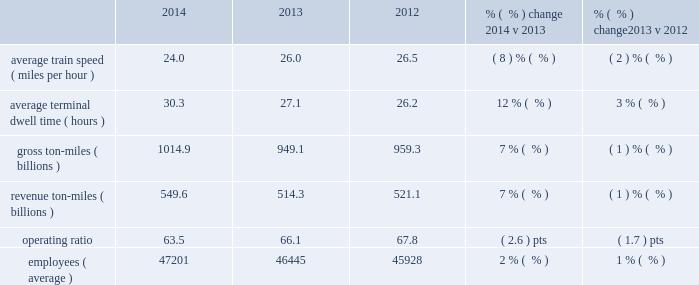Interest expense 2013 interest expense increased in 2014 versus 2013 due to an increased weighted- average debt level of $ 10.8 billion in 2014 from $ 9.6 billion in 2013 , which more than offset the impact of the lower effective interest rate of 5.3% ( 5.3 % ) in 2014 versus 5.7% ( 5.7 % ) in 2013 .
Interest expense decreased in 2013 versus 2012 due to a lower effective interest rate of 5.7% ( 5.7 % ) in 2013 versus 6.0% ( 6.0 % ) in 2012 .
The increase in the weighted-average debt level to $ 9.6 billion in 2013 from $ 9.1 billion in 2012 partially offset the impact of the lower effective interest rate .
Income taxes 2013 higher pre-tax income increased income taxes in 2014 compared to 2013 .
Our effective tax rate for 2014 was 37.9% ( 37.9 % ) compared to 37.7% ( 37.7 % ) in 2013 .
Higher pre-tax income increased income taxes in 2013 compared to 2012 .
Our effective tax rate for 2013 was 37.7% ( 37.7 % ) compared to 37.6% ( 37.6 % ) in 2012 .
Other operating/performance and financial statistics we report a number of key performance measures weekly to the association of american railroads ( aar ) .
We provide this data on our website at www.up.com/investor/aar-stb_reports/index.htm .
Operating/performance statistics railroad performance measures are included in the table below : 2014 2013 2012 % (  % ) change 2014 v 2013 % (  % ) change 2013 v 2012 .
Average train speed 2013 average train speed is calculated by dividing train miles by hours operated on our main lines between terminals .
Average train speed , as reported to the association of american railroads , decreased 8% ( 8 % ) in 2014 versus 2013 .
The decline was driven by a 7% ( 7 % ) volume increase , a major infrastructure project in fort worth , texas and inclement weather , including flooding in the midwest in the second quarter and severe weather conditions in the first quarter that impacted all major u.s .
And canadian railroads .
Average train speed decreased 2% ( 2 % ) in 2013 versus 2012 .
The decline was driven by severe weather conditions and shifts of traffic to sections of our network with higher utilization .
Average terminal dwell time 2013 average terminal dwell time is the average time that a rail car spends at our terminals .
Lower average terminal dwell time improves asset utilization and service .
Average terminal dwell time increased 12% ( 12 % ) in 2014 compared to 2013 , caused by higher volumes and inclement weather .
Average terminal dwell time increased 3% ( 3 % ) in 2013 compared to 2012 , primarily due to growth of manifest traffic which requires more time in terminals for switching cars and building trains .
Gross and revenue ton-miles 2013 gross ton-miles are calculated by multiplying the weight of loaded and empty freight cars by the number of miles hauled .
Revenue ton-miles are calculated by multiplying the weight of freight by the number of tariff miles .
Gross ton-miles , revenue ton-miles and carloadings all increased 7% ( 7 % ) in 2014 compared to 2013 .
Gross ton-miles and revenue ton-miles declined 1% ( 1 % ) in 2013 compared to 2012 and carloads remained relatively flat driven by declines in coal and agricultural products offset by growth in chemical , autos and industrial products .
Changes in commodity mix drove the year-over-year variances between gross ton- miles , revenue ton-miles and carloads. .
Holding weighted- average debt level as the same as 2013what would the interest expense be in 2014 in billions? 
Computations: (9.6 * 5.3%)
Answer: 0.5088. 